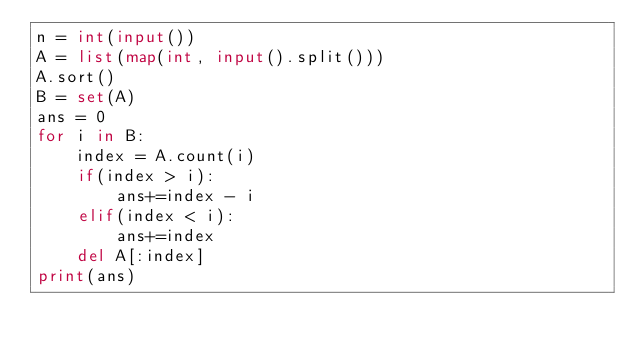<code> <loc_0><loc_0><loc_500><loc_500><_Python_>n = int(input())
A = list(map(int, input().split()))
A.sort()
B = set(A)
ans = 0
for i in B:
    index = A.count(i)
    if(index > i):
        ans+=index - i
    elif(index < i):
        ans+=index
    del A[:index]
print(ans)</code> 